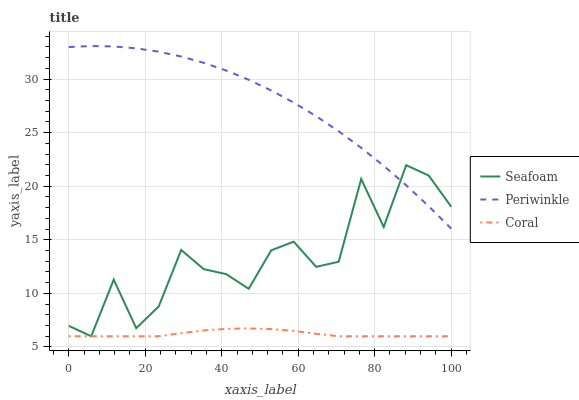Does Coral have the minimum area under the curve?
Answer yes or no. Yes. Does Periwinkle have the maximum area under the curve?
Answer yes or no. Yes. Does Seafoam have the minimum area under the curve?
Answer yes or no. No. Does Seafoam have the maximum area under the curve?
Answer yes or no. No. Is Coral the smoothest?
Answer yes or no. Yes. Is Seafoam the roughest?
Answer yes or no. Yes. Is Periwinkle the smoothest?
Answer yes or no. No. Is Periwinkle the roughest?
Answer yes or no. No. Does Coral have the lowest value?
Answer yes or no. Yes. Does Periwinkle have the lowest value?
Answer yes or no. No. Does Periwinkle have the highest value?
Answer yes or no. Yes. Does Seafoam have the highest value?
Answer yes or no. No. Is Coral less than Periwinkle?
Answer yes or no. Yes. Is Periwinkle greater than Coral?
Answer yes or no. Yes. Does Seafoam intersect Periwinkle?
Answer yes or no. Yes. Is Seafoam less than Periwinkle?
Answer yes or no. No. Is Seafoam greater than Periwinkle?
Answer yes or no. No. Does Coral intersect Periwinkle?
Answer yes or no. No. 